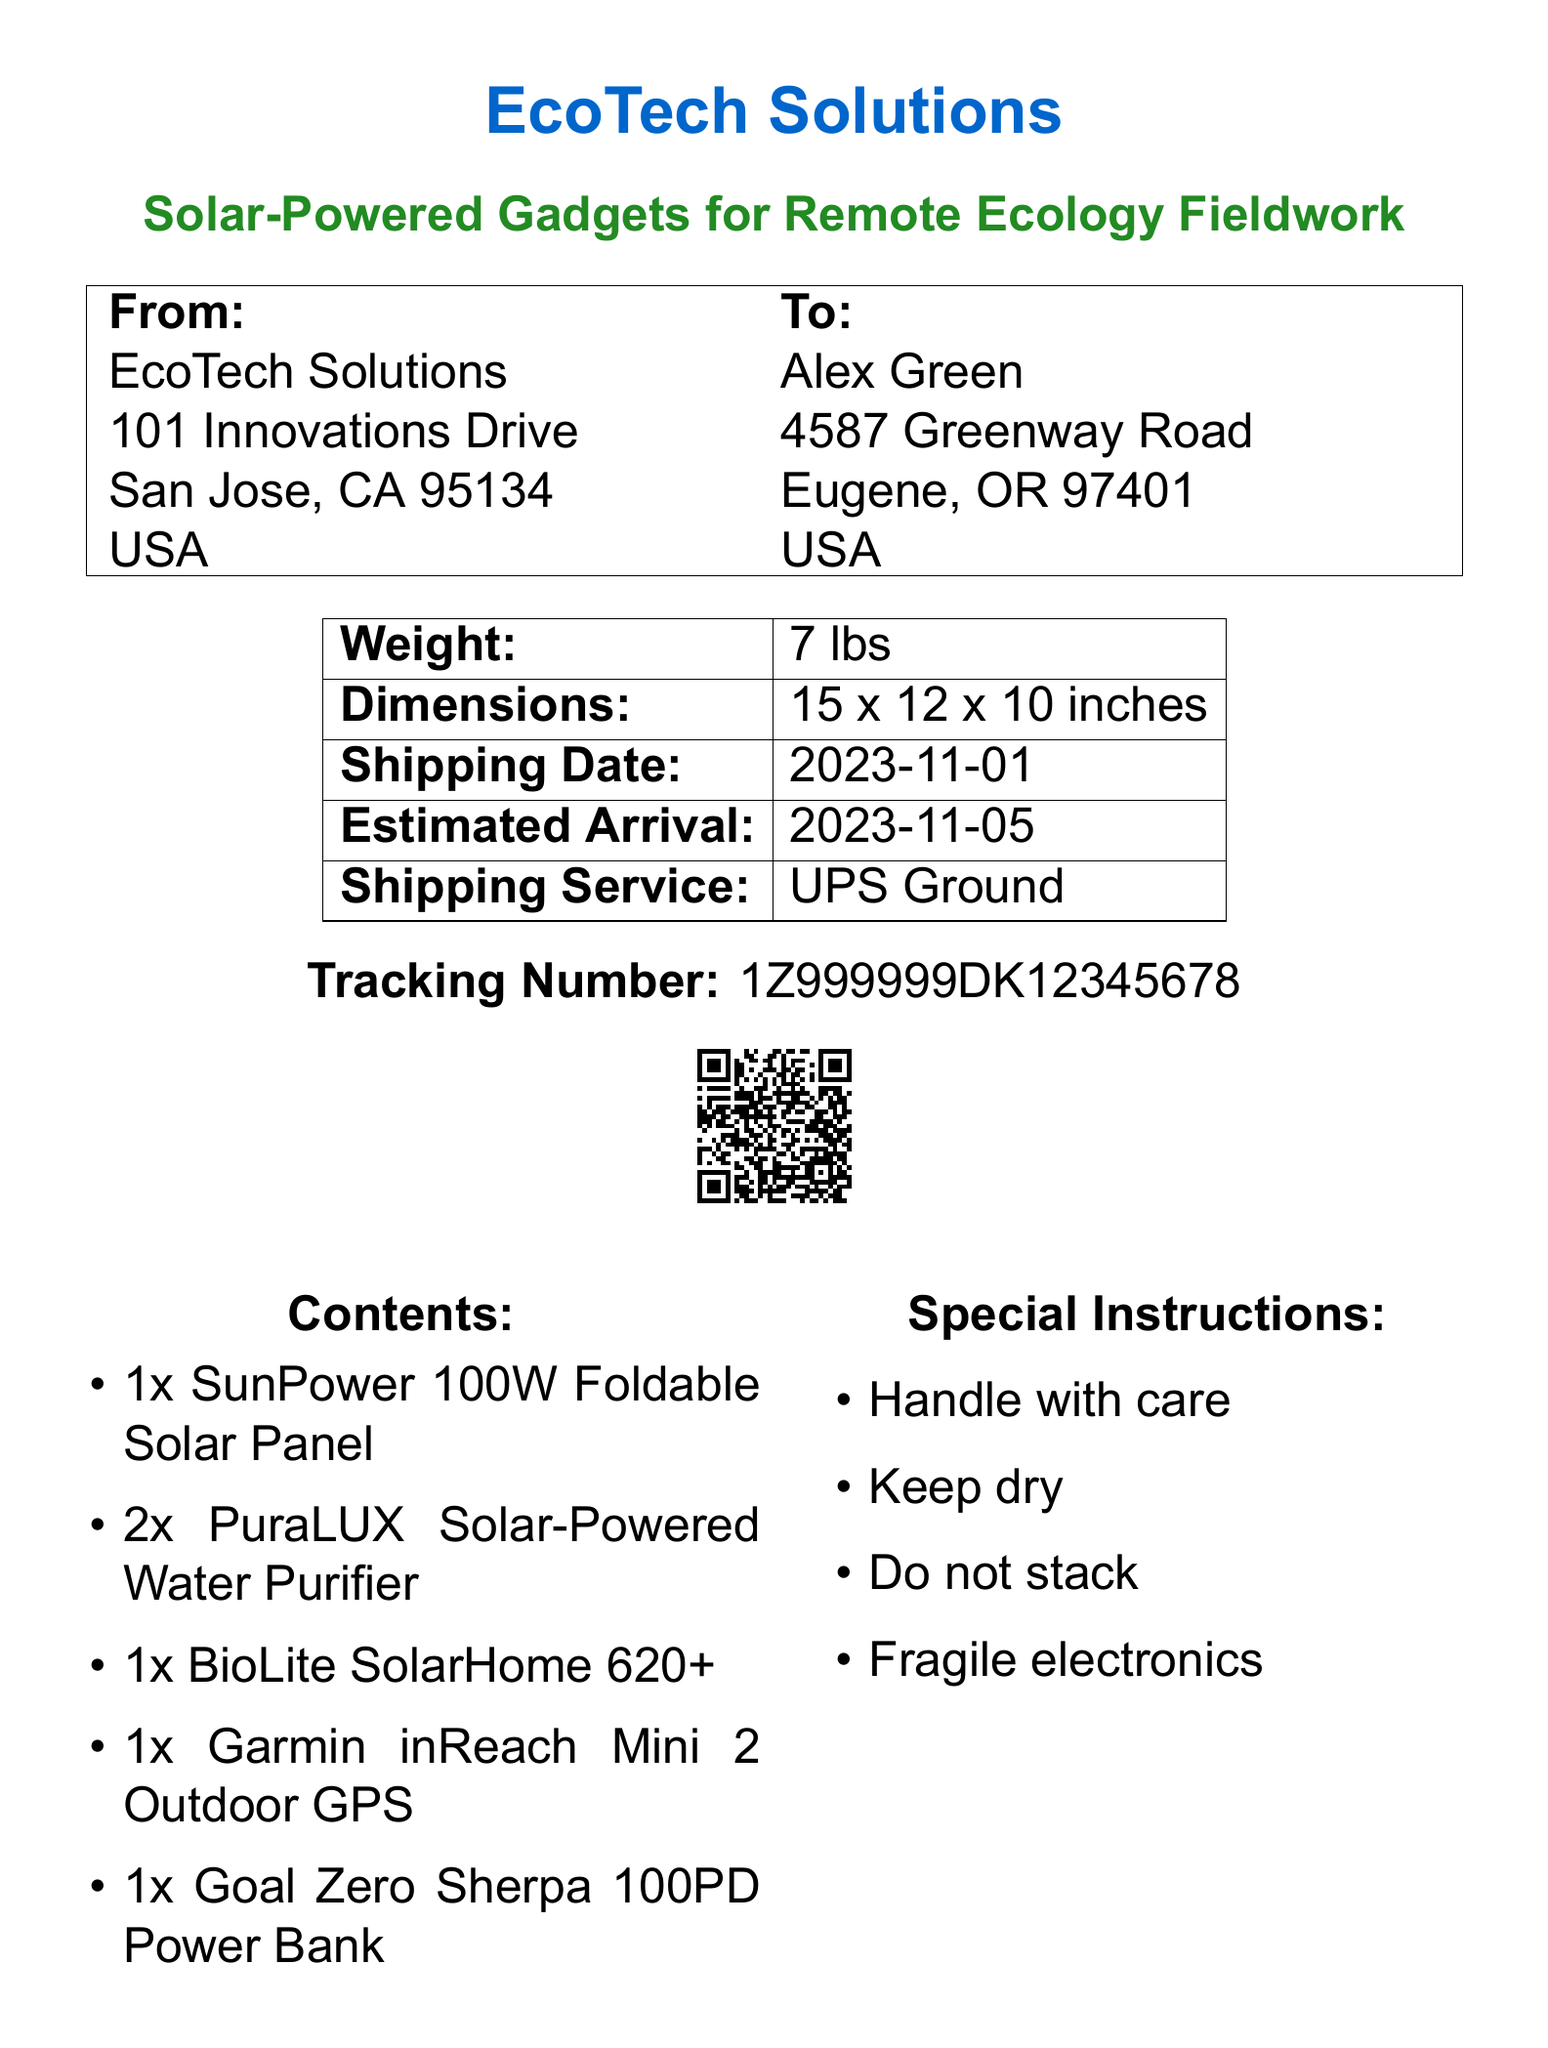What is the name of the sender? The sender's name is listed in the "From" section of the document, which is EcoTech Solutions.
Answer: EcoTech Solutions What is the destination city? The "To" section of the document specifies the city where the package is being sent, which is Eugene.
Answer: Eugene What is the weight of the package? The weight of the package is indicated in the table, which states that it is 7 lbs.
Answer: 7 lbs What is the estimated arrival date? The estimated arrival date is mentioned in the table, which is 2023-11-05.
Answer: 2023-11-05 How many solar-powered water purifiers are included? The contents section of the document shows the quantity of each item, which specifies 2 units of PuraLUX Solar-Powered Water Purifier.
Answer: 2x What shipping service is used for the delivery? The shipping service is noted in the table, which is UPS Ground.
Answer: UPS Ground What special instruction is given regarding handling? The document states that the package should be handled with care based on the "Special Instructions" section.
Answer: Handle with care What type of electronic is mentioned in the special instructions? The special instruction section notes that the contents include fragile electronics.
Answer: Fragile electronics How many items are listed in total in the contents? The list of contents totals five different items based on the itemized list provided.
Answer: 5 items 